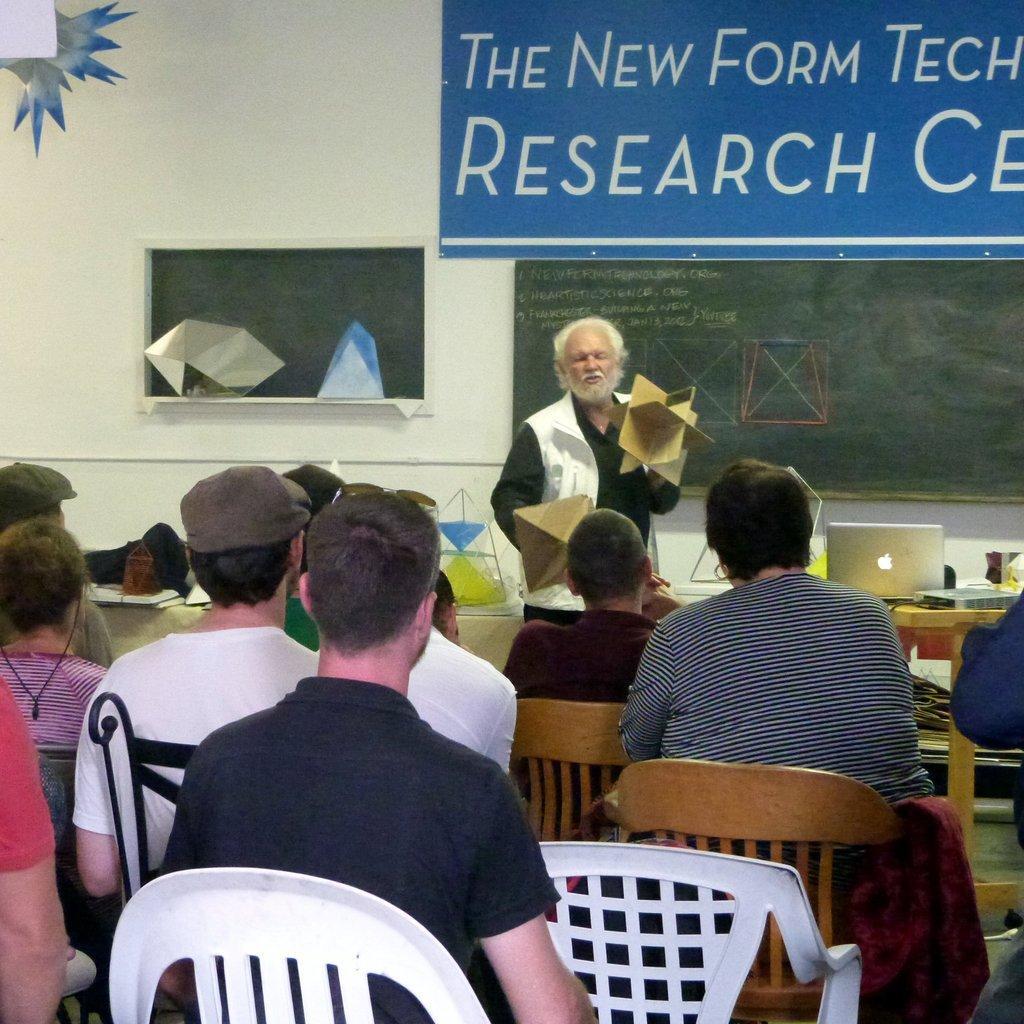Please provide a concise description of this image. In this image i can see few people sitting on a chair at the back ground i can see man standing a board, and a wall. 